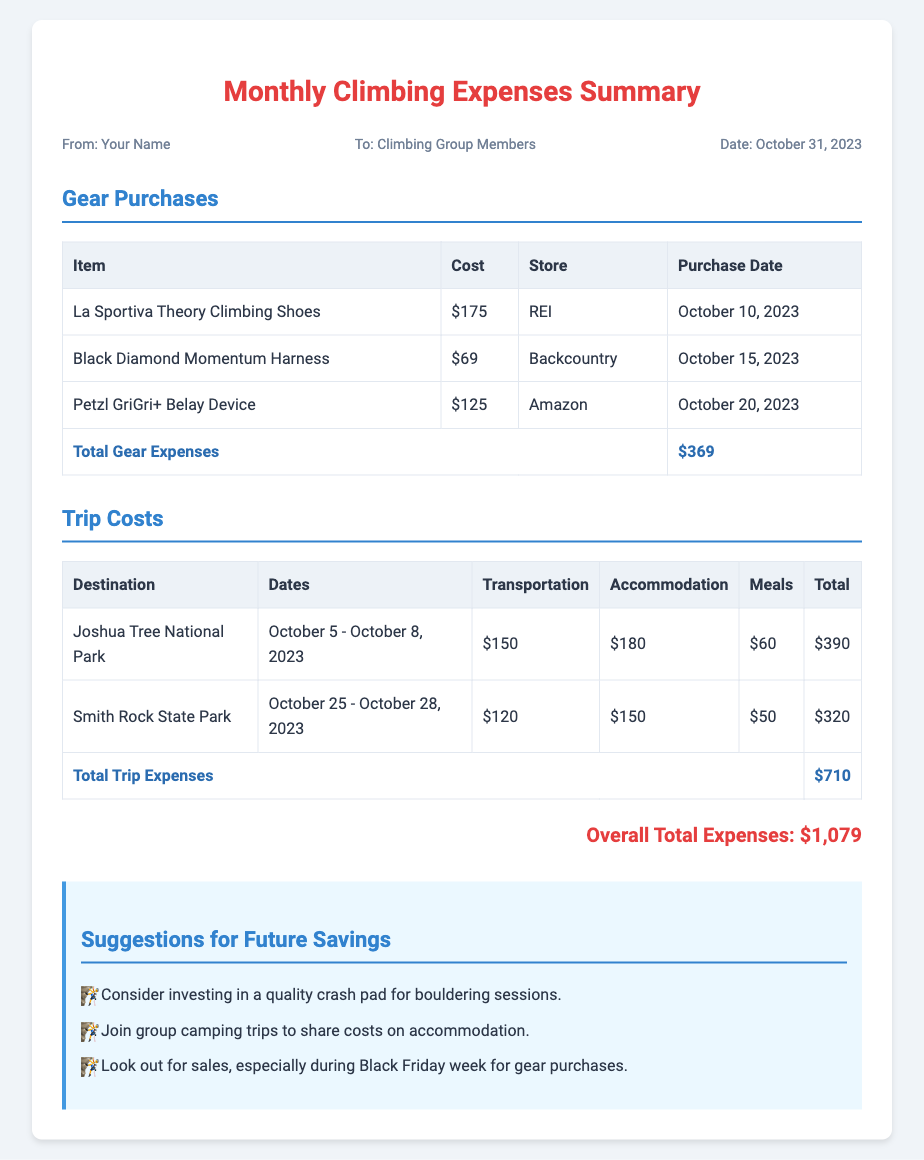What is the total cost of gear purchases? The total cost of gear purchases is listed at the bottom of the gear purchases table, which sums the individual costs of gear items.
Answer: $369 How much did the trip to Joshua Tree National Park cost? This cost is detailed in the trip costs section. The total amount for the trip is listed at the end of the row for Joshua Tree.
Answer: $390 What item was purchased on October 20, 2023? The specific item purchased on this date can be found under the purchase date column in the gear purchases table.
Answer: Petzl GriGri+ Belay Device What is the overall total expenses? The overall total expenses are found in the last section of the document, which adds all expenses together.
Answer: $1,079 How many days did the trip to Smith Rock State Park last? The duration of the trip can be calculated from the dates provided in the trip costs table.
Answer: 3 days What suggestions are offered for future savings? The suggestions section lists ideas to save costs on climbing expenses.
Answer: Investing in a quality crash pad for bouldering sessions What was the cost for meals during the trip to Smith Rock State Park? The cost for meals is specified in the trip costs table alongside other expense categories for the trip.
Answer: $50 What store did the purchase of the Black Diamond Momentum Harness take place? The store name is in the gear purchases table next to the item and corresponding cost.
Answer: Backcountry 